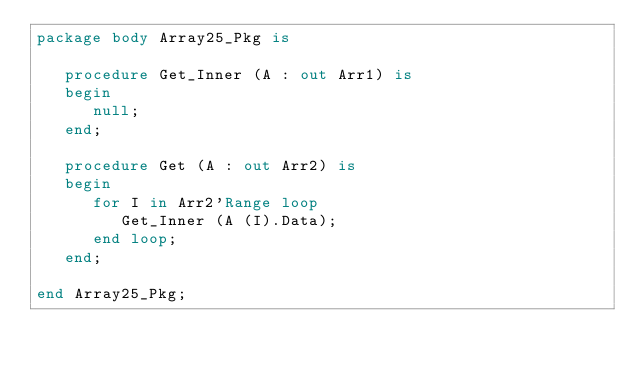Convert code to text. <code><loc_0><loc_0><loc_500><loc_500><_Ada_>package body Array25_Pkg is

   procedure Get_Inner (A : out Arr1) is
   begin
      null;
   end;

   procedure Get (A : out Arr2) is
   begin
      for I in Arr2'Range loop
         Get_Inner (A (I).Data);
      end loop;
   end;

end Array25_Pkg;
</code> 